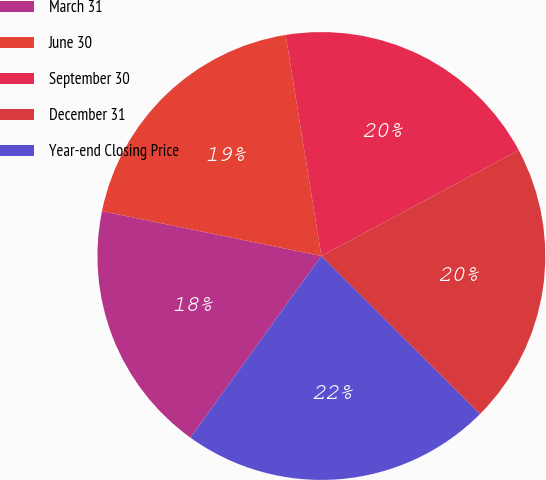<chart> <loc_0><loc_0><loc_500><loc_500><pie_chart><fcel>March 31<fcel>June 30<fcel>September 30<fcel>December 31<fcel>Year-end Closing Price<nl><fcel>18.27%<fcel>19.24%<fcel>19.72%<fcel>20.31%<fcel>22.46%<nl></chart> 